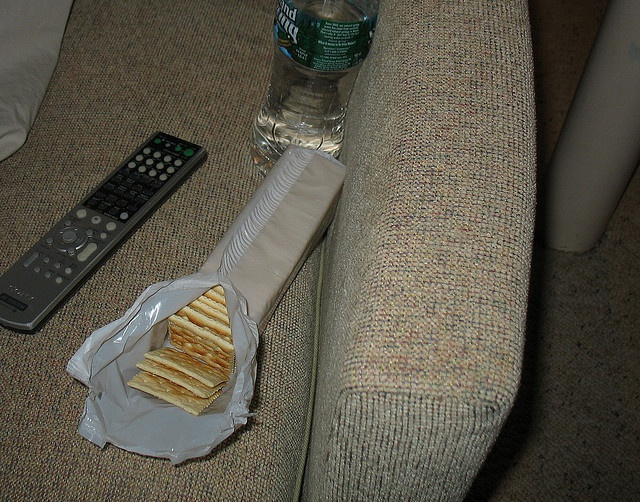Describe the objects in this image and their specific colors. I can see couch in gray and black tones, remote in gray, black, and darkgreen tones, and bottle in gray, black, and darkgray tones in this image. 